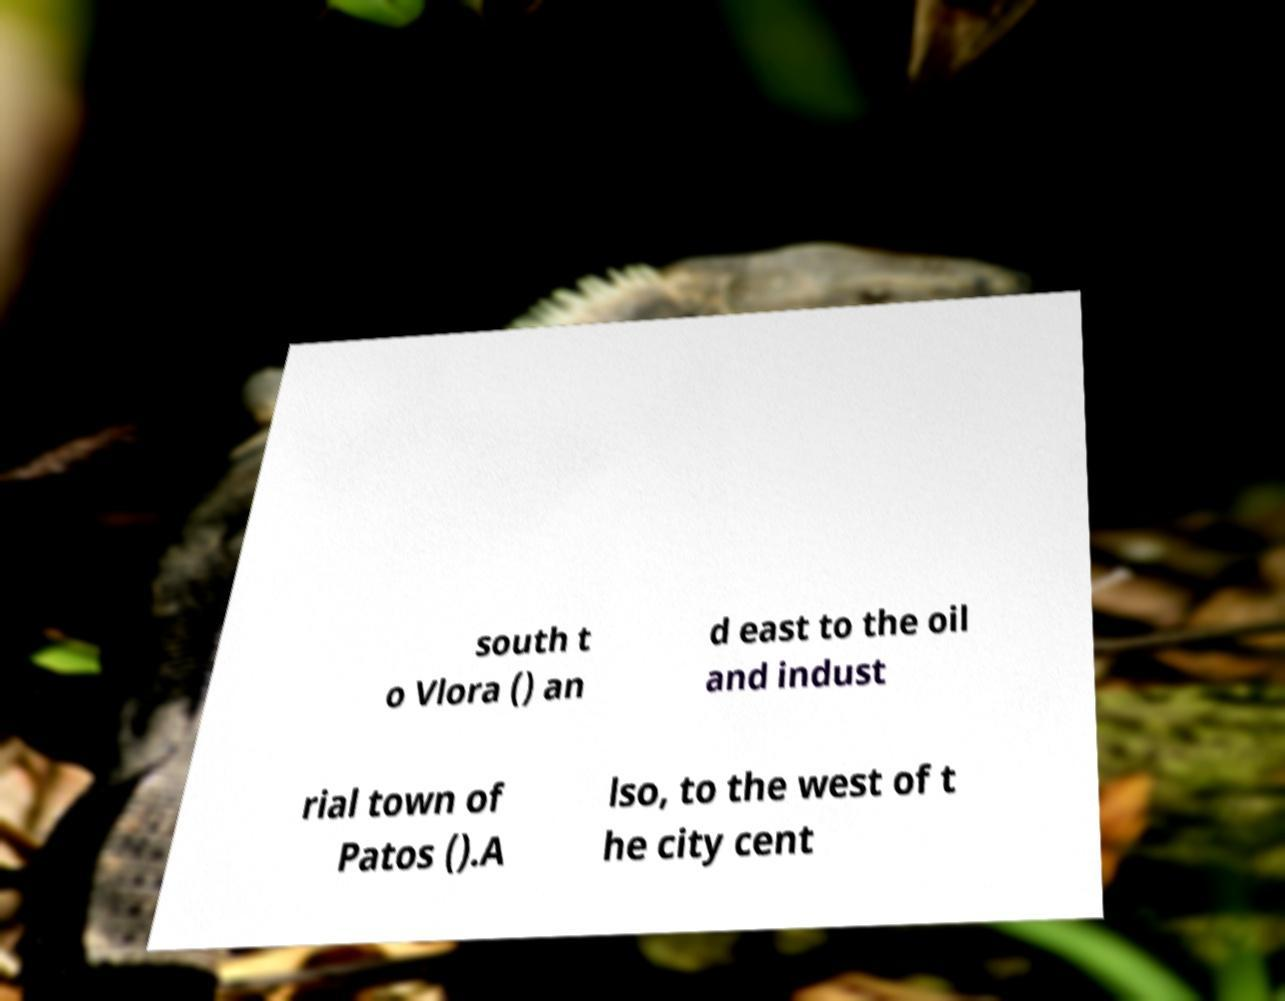For documentation purposes, I need the text within this image transcribed. Could you provide that? south t o Vlora () an d east to the oil and indust rial town of Patos ().A lso, to the west of t he city cent 